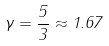Convert formula to latex. <formula><loc_0><loc_0><loc_500><loc_500>\gamma = \frac { 5 } { 3 } \approx 1 . 6 7</formula> 